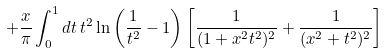<formula> <loc_0><loc_0><loc_500><loc_500>+ \frac { x } { \pi } \int _ { 0 } ^ { 1 } d t \, t ^ { 2 } \ln \left ( \frac { 1 } { t ^ { 2 } } - 1 \right ) \left [ \frac { 1 } { ( 1 + x ^ { 2 } t ^ { 2 } ) ^ { 2 } } + \frac { 1 } { ( x ^ { 2 } + t ^ { 2 } ) ^ { 2 } } \right ]</formula> 